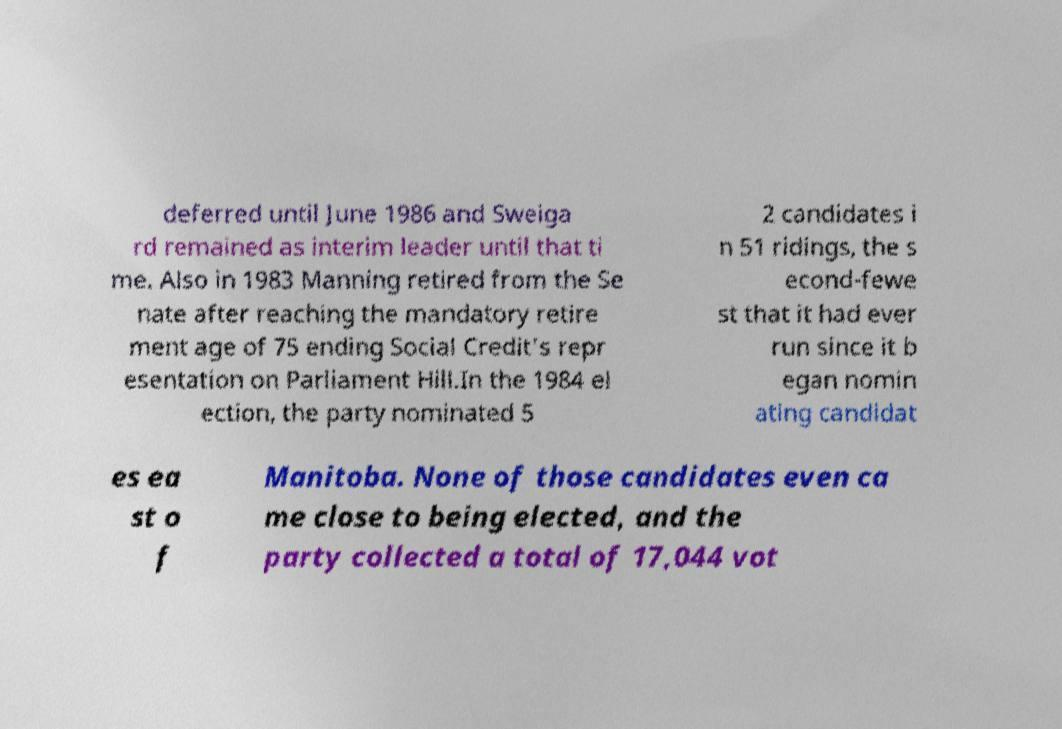Please read and relay the text visible in this image. What does it say? deferred until June 1986 and Sweiga rd remained as interim leader until that ti me. Also in 1983 Manning retired from the Se nate after reaching the mandatory retire ment age of 75 ending Social Credit's repr esentation on Parliament Hill.In the 1984 el ection, the party nominated 5 2 candidates i n 51 ridings, the s econd-fewe st that it had ever run since it b egan nomin ating candidat es ea st o f Manitoba. None of those candidates even ca me close to being elected, and the party collected a total of 17,044 vot 